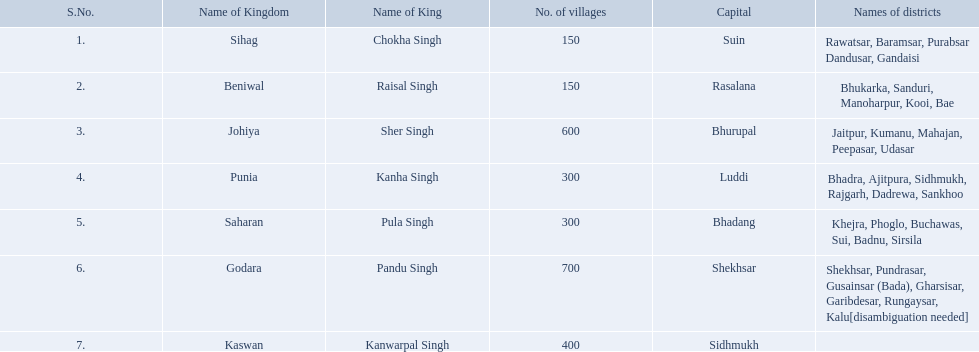What is the most amount of villages in a kingdom? 700. What is the second most amount of villages in a kingdom? 600. What kingdom has 600 villages? Johiya. What are all of the kingdoms? Sihag, Beniwal, Johiya, Punia, Saharan, Godara, Kaswan. How many villages do they contain? 150, 150, 600, 300, 300, 700, 400. How many are in godara? 700. Which kingdom comes next in highest amount of villages? Johiya. Which kingdom contained the least amount of villages along with sihag? Beniwal. Which kingdom contained the most villages? Godara. Which village was tied at second most villages with godara? Johiya. What is the greatest quantity of villages in a monarchy? 700. What is the second greatest quantity of villages in a monarchy? 600. Which monarchy has 600 villages? Johiya. What is the largest number of villages in a kingdom? 700. What is the second largest number of villages in a kingdom? 600. Which kingdom contains 600 villages? Johiya. What is the maximum number of villages present in a kingdom? 700. What is the second highest number of villages in a kingdom? 600. Which kingdom consists of 600 villages? Johiya. What is the greatest number of villages that a kingdom can have? 700. Which kingdom has the next highest number of villages? 600. In which kingdom can we find 600 villages? Johiya. Which kingdom had the smallest number of villages, including sihag? Beniwal. Which kingdom had the largest number of villages? Godara. Which village shared the second-highest number of villages with godara? Johiya. 